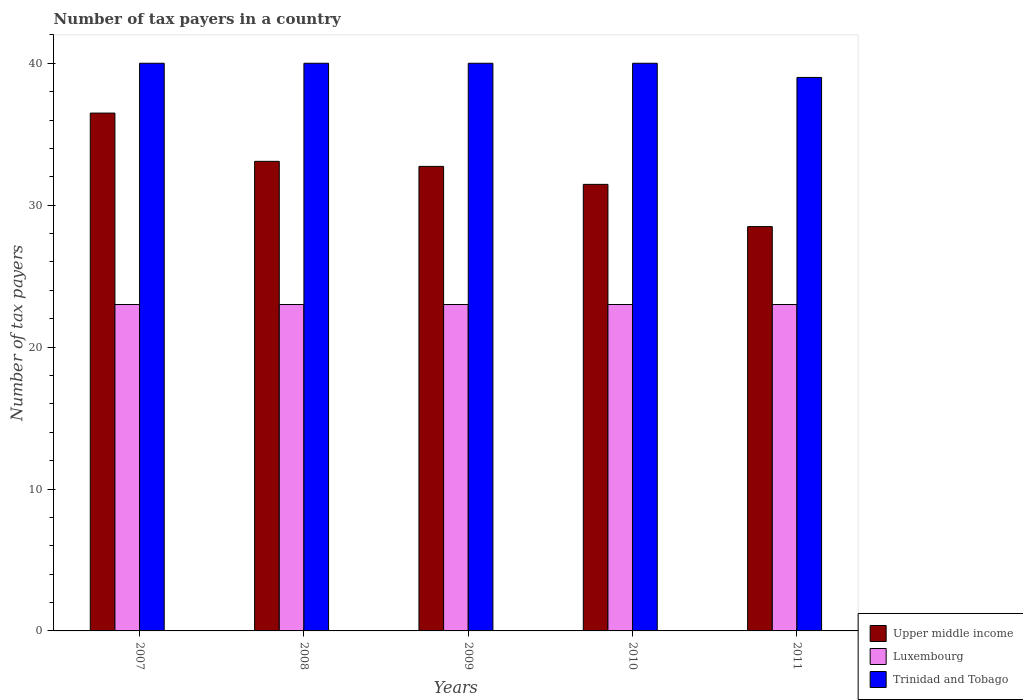How many different coloured bars are there?
Provide a short and direct response. 3. How many groups of bars are there?
Your answer should be compact. 5. Are the number of bars per tick equal to the number of legend labels?
Make the answer very short. Yes. How many bars are there on the 5th tick from the left?
Provide a short and direct response. 3. What is the label of the 3rd group of bars from the left?
Provide a short and direct response. 2009. In how many cases, is the number of bars for a given year not equal to the number of legend labels?
Provide a succinct answer. 0. What is the number of tax payers in in Luxembourg in 2007?
Ensure brevity in your answer.  23. Across all years, what is the minimum number of tax payers in in Luxembourg?
Keep it short and to the point. 23. In which year was the number of tax payers in in Trinidad and Tobago maximum?
Give a very brief answer. 2007. In which year was the number of tax payers in in Luxembourg minimum?
Keep it short and to the point. 2007. What is the total number of tax payers in in Trinidad and Tobago in the graph?
Keep it short and to the point. 199. What is the difference between the number of tax payers in in Trinidad and Tobago in 2009 and that in 2011?
Give a very brief answer. 1. What is the difference between the number of tax payers in in Luxembourg in 2008 and the number of tax payers in in Upper middle income in 2010?
Your answer should be compact. -8.47. What is the average number of tax payers in in Upper middle income per year?
Offer a terse response. 32.45. In the year 2009, what is the difference between the number of tax payers in in Trinidad and Tobago and number of tax payers in in Upper middle income?
Offer a very short reply. 7.27. In how many years, is the number of tax payers in in Trinidad and Tobago greater than 6?
Offer a terse response. 5. What is the ratio of the number of tax payers in in Upper middle income in 2009 to that in 2010?
Keep it short and to the point. 1.04. Is the difference between the number of tax payers in in Trinidad and Tobago in 2008 and 2010 greater than the difference between the number of tax payers in in Upper middle income in 2008 and 2010?
Your response must be concise. No. What is the difference between the highest and the lowest number of tax payers in in Luxembourg?
Ensure brevity in your answer.  0. What does the 3rd bar from the left in 2009 represents?
Give a very brief answer. Trinidad and Tobago. What does the 3rd bar from the right in 2008 represents?
Provide a short and direct response. Upper middle income. Is it the case that in every year, the sum of the number of tax payers in in Upper middle income and number of tax payers in in Trinidad and Tobago is greater than the number of tax payers in in Luxembourg?
Give a very brief answer. Yes. How many bars are there?
Your response must be concise. 15. Are all the bars in the graph horizontal?
Offer a very short reply. No. How many years are there in the graph?
Your response must be concise. 5. Does the graph contain any zero values?
Give a very brief answer. No. Does the graph contain grids?
Offer a very short reply. No. How many legend labels are there?
Keep it short and to the point. 3. What is the title of the graph?
Ensure brevity in your answer.  Number of tax payers in a country. What is the label or title of the Y-axis?
Your answer should be very brief. Number of tax payers. What is the Number of tax payers of Upper middle income in 2007?
Your answer should be very brief. 36.49. What is the Number of tax payers of Upper middle income in 2008?
Provide a succinct answer. 33.09. What is the Number of tax payers of Upper middle income in 2009?
Provide a short and direct response. 32.73. What is the Number of tax payers of Luxembourg in 2009?
Make the answer very short. 23. What is the Number of tax payers of Trinidad and Tobago in 2009?
Your answer should be very brief. 40. What is the Number of tax payers in Upper middle income in 2010?
Make the answer very short. 31.47. What is the Number of tax payers in Luxembourg in 2010?
Your answer should be compact. 23. What is the Number of tax payers in Upper middle income in 2011?
Your response must be concise. 28.49. What is the Number of tax payers of Luxembourg in 2011?
Provide a short and direct response. 23. What is the Number of tax payers of Trinidad and Tobago in 2011?
Your response must be concise. 39. Across all years, what is the maximum Number of tax payers in Upper middle income?
Your answer should be very brief. 36.49. Across all years, what is the minimum Number of tax payers in Upper middle income?
Provide a succinct answer. 28.49. Across all years, what is the minimum Number of tax payers of Luxembourg?
Your response must be concise. 23. What is the total Number of tax payers of Upper middle income in the graph?
Keep it short and to the point. 162.27. What is the total Number of tax payers of Luxembourg in the graph?
Make the answer very short. 115. What is the total Number of tax payers of Trinidad and Tobago in the graph?
Provide a succinct answer. 199. What is the difference between the Number of tax payers of Upper middle income in 2007 and that in 2009?
Make the answer very short. 3.76. What is the difference between the Number of tax payers of Luxembourg in 2007 and that in 2009?
Keep it short and to the point. 0. What is the difference between the Number of tax payers in Upper middle income in 2007 and that in 2010?
Your response must be concise. 5.02. What is the difference between the Number of tax payers of Trinidad and Tobago in 2007 and that in 2010?
Offer a terse response. 0. What is the difference between the Number of tax payers of Luxembourg in 2007 and that in 2011?
Offer a terse response. 0. What is the difference between the Number of tax payers in Upper middle income in 2008 and that in 2009?
Make the answer very short. 0.36. What is the difference between the Number of tax payers in Trinidad and Tobago in 2008 and that in 2009?
Your response must be concise. 0. What is the difference between the Number of tax payers of Upper middle income in 2008 and that in 2010?
Offer a very short reply. 1.62. What is the difference between the Number of tax payers in Trinidad and Tobago in 2008 and that in 2011?
Ensure brevity in your answer.  1. What is the difference between the Number of tax payers of Upper middle income in 2009 and that in 2010?
Your answer should be compact. 1.27. What is the difference between the Number of tax payers of Upper middle income in 2009 and that in 2011?
Provide a succinct answer. 4.24. What is the difference between the Number of tax payers in Upper middle income in 2010 and that in 2011?
Give a very brief answer. 2.98. What is the difference between the Number of tax payers of Luxembourg in 2010 and that in 2011?
Make the answer very short. 0. What is the difference between the Number of tax payers in Upper middle income in 2007 and the Number of tax payers in Luxembourg in 2008?
Your response must be concise. 13.49. What is the difference between the Number of tax payers in Upper middle income in 2007 and the Number of tax payers in Trinidad and Tobago in 2008?
Offer a terse response. -3.51. What is the difference between the Number of tax payers of Luxembourg in 2007 and the Number of tax payers of Trinidad and Tobago in 2008?
Ensure brevity in your answer.  -17. What is the difference between the Number of tax payers in Upper middle income in 2007 and the Number of tax payers in Luxembourg in 2009?
Provide a succinct answer. 13.49. What is the difference between the Number of tax payers in Upper middle income in 2007 and the Number of tax payers in Trinidad and Tobago in 2009?
Give a very brief answer. -3.51. What is the difference between the Number of tax payers of Upper middle income in 2007 and the Number of tax payers of Luxembourg in 2010?
Provide a short and direct response. 13.49. What is the difference between the Number of tax payers in Upper middle income in 2007 and the Number of tax payers in Trinidad and Tobago in 2010?
Give a very brief answer. -3.51. What is the difference between the Number of tax payers in Luxembourg in 2007 and the Number of tax payers in Trinidad and Tobago in 2010?
Offer a terse response. -17. What is the difference between the Number of tax payers in Upper middle income in 2007 and the Number of tax payers in Luxembourg in 2011?
Provide a succinct answer. 13.49. What is the difference between the Number of tax payers of Upper middle income in 2007 and the Number of tax payers of Trinidad and Tobago in 2011?
Give a very brief answer. -2.51. What is the difference between the Number of tax payers of Luxembourg in 2007 and the Number of tax payers of Trinidad and Tobago in 2011?
Your answer should be very brief. -16. What is the difference between the Number of tax payers of Upper middle income in 2008 and the Number of tax payers of Luxembourg in 2009?
Offer a very short reply. 10.09. What is the difference between the Number of tax payers of Upper middle income in 2008 and the Number of tax payers of Trinidad and Tobago in 2009?
Offer a very short reply. -6.91. What is the difference between the Number of tax payers in Luxembourg in 2008 and the Number of tax payers in Trinidad and Tobago in 2009?
Offer a very short reply. -17. What is the difference between the Number of tax payers of Upper middle income in 2008 and the Number of tax payers of Luxembourg in 2010?
Your answer should be compact. 10.09. What is the difference between the Number of tax payers in Upper middle income in 2008 and the Number of tax payers in Trinidad and Tobago in 2010?
Provide a short and direct response. -6.91. What is the difference between the Number of tax payers of Upper middle income in 2008 and the Number of tax payers of Luxembourg in 2011?
Provide a succinct answer. 10.09. What is the difference between the Number of tax payers of Upper middle income in 2008 and the Number of tax payers of Trinidad and Tobago in 2011?
Offer a terse response. -5.91. What is the difference between the Number of tax payers in Upper middle income in 2009 and the Number of tax payers in Luxembourg in 2010?
Offer a terse response. 9.73. What is the difference between the Number of tax payers in Upper middle income in 2009 and the Number of tax payers in Trinidad and Tobago in 2010?
Keep it short and to the point. -7.27. What is the difference between the Number of tax payers in Upper middle income in 2009 and the Number of tax payers in Luxembourg in 2011?
Make the answer very short. 9.73. What is the difference between the Number of tax payers of Upper middle income in 2009 and the Number of tax payers of Trinidad and Tobago in 2011?
Provide a short and direct response. -6.27. What is the difference between the Number of tax payers in Upper middle income in 2010 and the Number of tax payers in Luxembourg in 2011?
Offer a terse response. 8.47. What is the difference between the Number of tax payers in Upper middle income in 2010 and the Number of tax payers in Trinidad and Tobago in 2011?
Your answer should be very brief. -7.53. What is the difference between the Number of tax payers of Luxembourg in 2010 and the Number of tax payers of Trinidad and Tobago in 2011?
Provide a short and direct response. -16. What is the average Number of tax payers in Upper middle income per year?
Provide a short and direct response. 32.45. What is the average Number of tax payers in Trinidad and Tobago per year?
Offer a very short reply. 39.8. In the year 2007, what is the difference between the Number of tax payers in Upper middle income and Number of tax payers in Luxembourg?
Keep it short and to the point. 13.49. In the year 2007, what is the difference between the Number of tax payers in Upper middle income and Number of tax payers in Trinidad and Tobago?
Ensure brevity in your answer.  -3.51. In the year 2007, what is the difference between the Number of tax payers in Luxembourg and Number of tax payers in Trinidad and Tobago?
Your answer should be compact. -17. In the year 2008, what is the difference between the Number of tax payers of Upper middle income and Number of tax payers of Luxembourg?
Ensure brevity in your answer.  10.09. In the year 2008, what is the difference between the Number of tax payers in Upper middle income and Number of tax payers in Trinidad and Tobago?
Your response must be concise. -6.91. In the year 2009, what is the difference between the Number of tax payers of Upper middle income and Number of tax payers of Luxembourg?
Give a very brief answer. 9.73. In the year 2009, what is the difference between the Number of tax payers in Upper middle income and Number of tax payers in Trinidad and Tobago?
Give a very brief answer. -7.27. In the year 2010, what is the difference between the Number of tax payers of Upper middle income and Number of tax payers of Luxembourg?
Ensure brevity in your answer.  8.47. In the year 2010, what is the difference between the Number of tax payers in Upper middle income and Number of tax payers in Trinidad and Tobago?
Ensure brevity in your answer.  -8.53. In the year 2010, what is the difference between the Number of tax payers in Luxembourg and Number of tax payers in Trinidad and Tobago?
Provide a short and direct response. -17. In the year 2011, what is the difference between the Number of tax payers in Upper middle income and Number of tax payers in Luxembourg?
Make the answer very short. 5.49. In the year 2011, what is the difference between the Number of tax payers in Upper middle income and Number of tax payers in Trinidad and Tobago?
Give a very brief answer. -10.51. In the year 2011, what is the difference between the Number of tax payers in Luxembourg and Number of tax payers in Trinidad and Tobago?
Your response must be concise. -16. What is the ratio of the Number of tax payers in Upper middle income in 2007 to that in 2008?
Ensure brevity in your answer.  1.1. What is the ratio of the Number of tax payers of Trinidad and Tobago in 2007 to that in 2008?
Offer a very short reply. 1. What is the ratio of the Number of tax payers of Upper middle income in 2007 to that in 2009?
Your answer should be compact. 1.11. What is the ratio of the Number of tax payers of Luxembourg in 2007 to that in 2009?
Offer a very short reply. 1. What is the ratio of the Number of tax payers of Upper middle income in 2007 to that in 2010?
Provide a short and direct response. 1.16. What is the ratio of the Number of tax payers in Trinidad and Tobago in 2007 to that in 2010?
Provide a succinct answer. 1. What is the ratio of the Number of tax payers in Upper middle income in 2007 to that in 2011?
Provide a short and direct response. 1.28. What is the ratio of the Number of tax payers in Trinidad and Tobago in 2007 to that in 2011?
Ensure brevity in your answer.  1.03. What is the ratio of the Number of tax payers of Upper middle income in 2008 to that in 2009?
Your response must be concise. 1.01. What is the ratio of the Number of tax payers of Luxembourg in 2008 to that in 2009?
Provide a short and direct response. 1. What is the ratio of the Number of tax payers of Trinidad and Tobago in 2008 to that in 2009?
Offer a terse response. 1. What is the ratio of the Number of tax payers in Upper middle income in 2008 to that in 2010?
Offer a very short reply. 1.05. What is the ratio of the Number of tax payers of Luxembourg in 2008 to that in 2010?
Your answer should be very brief. 1. What is the ratio of the Number of tax payers of Upper middle income in 2008 to that in 2011?
Offer a terse response. 1.16. What is the ratio of the Number of tax payers in Trinidad and Tobago in 2008 to that in 2011?
Offer a terse response. 1.03. What is the ratio of the Number of tax payers of Upper middle income in 2009 to that in 2010?
Ensure brevity in your answer.  1.04. What is the ratio of the Number of tax payers in Luxembourg in 2009 to that in 2010?
Your response must be concise. 1. What is the ratio of the Number of tax payers of Trinidad and Tobago in 2009 to that in 2010?
Make the answer very short. 1. What is the ratio of the Number of tax payers of Upper middle income in 2009 to that in 2011?
Keep it short and to the point. 1.15. What is the ratio of the Number of tax payers in Trinidad and Tobago in 2009 to that in 2011?
Offer a very short reply. 1.03. What is the ratio of the Number of tax payers of Upper middle income in 2010 to that in 2011?
Provide a short and direct response. 1.1. What is the ratio of the Number of tax payers of Luxembourg in 2010 to that in 2011?
Give a very brief answer. 1. What is the ratio of the Number of tax payers of Trinidad and Tobago in 2010 to that in 2011?
Offer a terse response. 1.03. What is the difference between the highest and the second highest Number of tax payers in Upper middle income?
Your answer should be compact. 3.4. What is the difference between the highest and the second highest Number of tax payers of Luxembourg?
Your answer should be very brief. 0. What is the difference between the highest and the second highest Number of tax payers of Trinidad and Tobago?
Give a very brief answer. 0. 